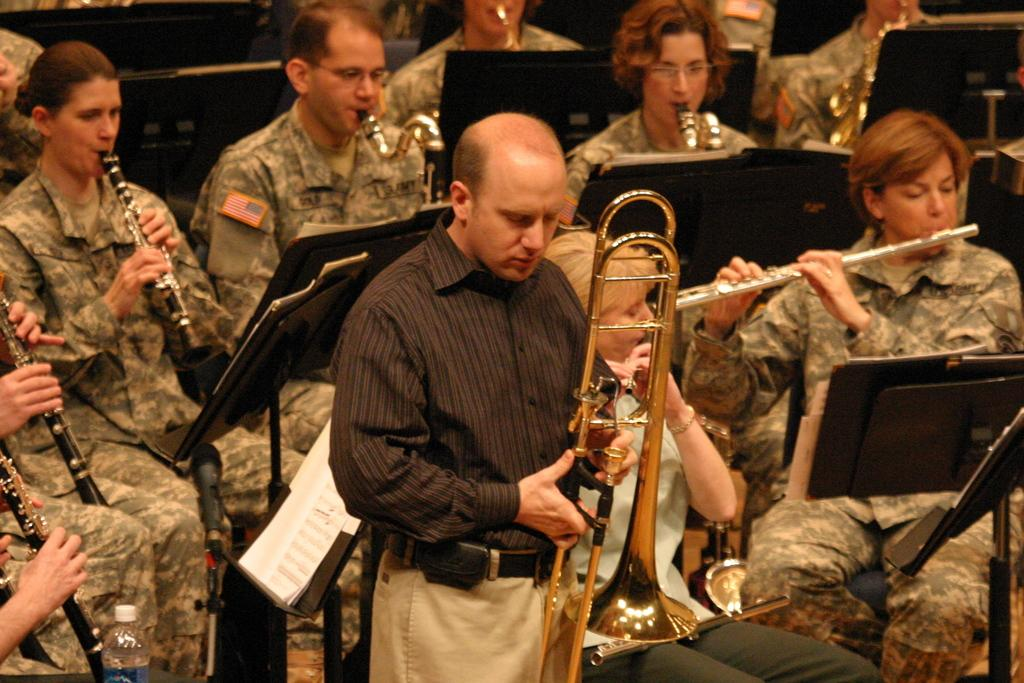Who or what can be seen in the image? There are people in the image. What are the people doing in the image? The presence of musical instruments suggests that the people might be playing music. What else is visible in the image besides the people and musical instruments? There is a bottle and other objects in the image. What type of skirt is the tree wearing in the image? There is no tree or skirt present in the image. Can you tell me how many berries are on the ground in the image? There are no berries visible in the image. 